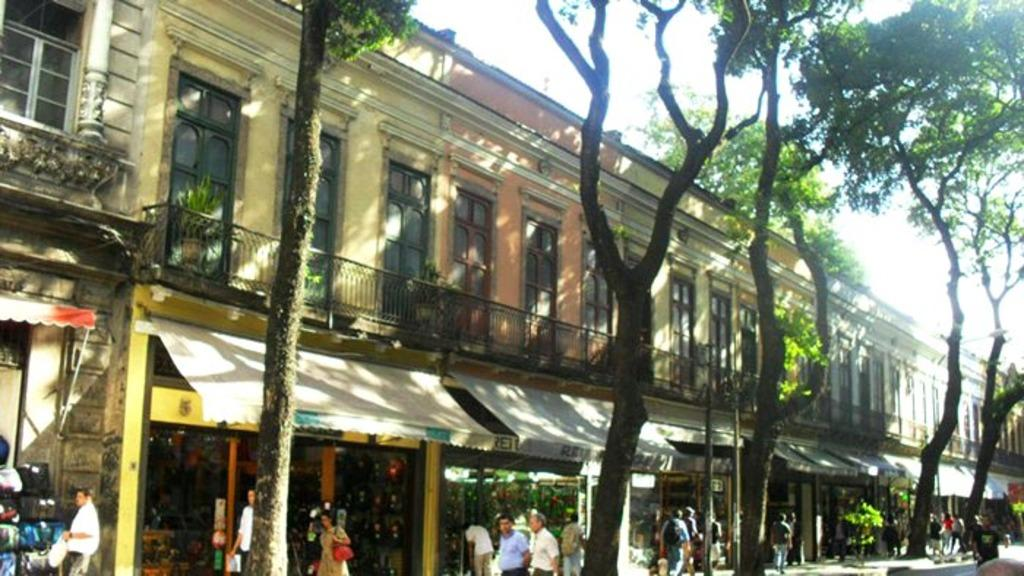What type of structures can be seen in the image? There are buildings in the image. What natural elements are present in the image? There are trees and plants in the image. What type of establishments can be found in the image? There are stores in the image. Are there any living beings visible in the image? Yes, there are people in the image. What part of the natural environment is visible in the image? The sky is visible in the image. What architectural feature can be seen in the image? There is a railing in the image. What else can be found in the image besides the mentioned elements? There are objects in the image. What type of current can be seen flowing through the faucet in the image? There is no faucet present in the image, so it is not possible to determine if any current is flowing through it. 